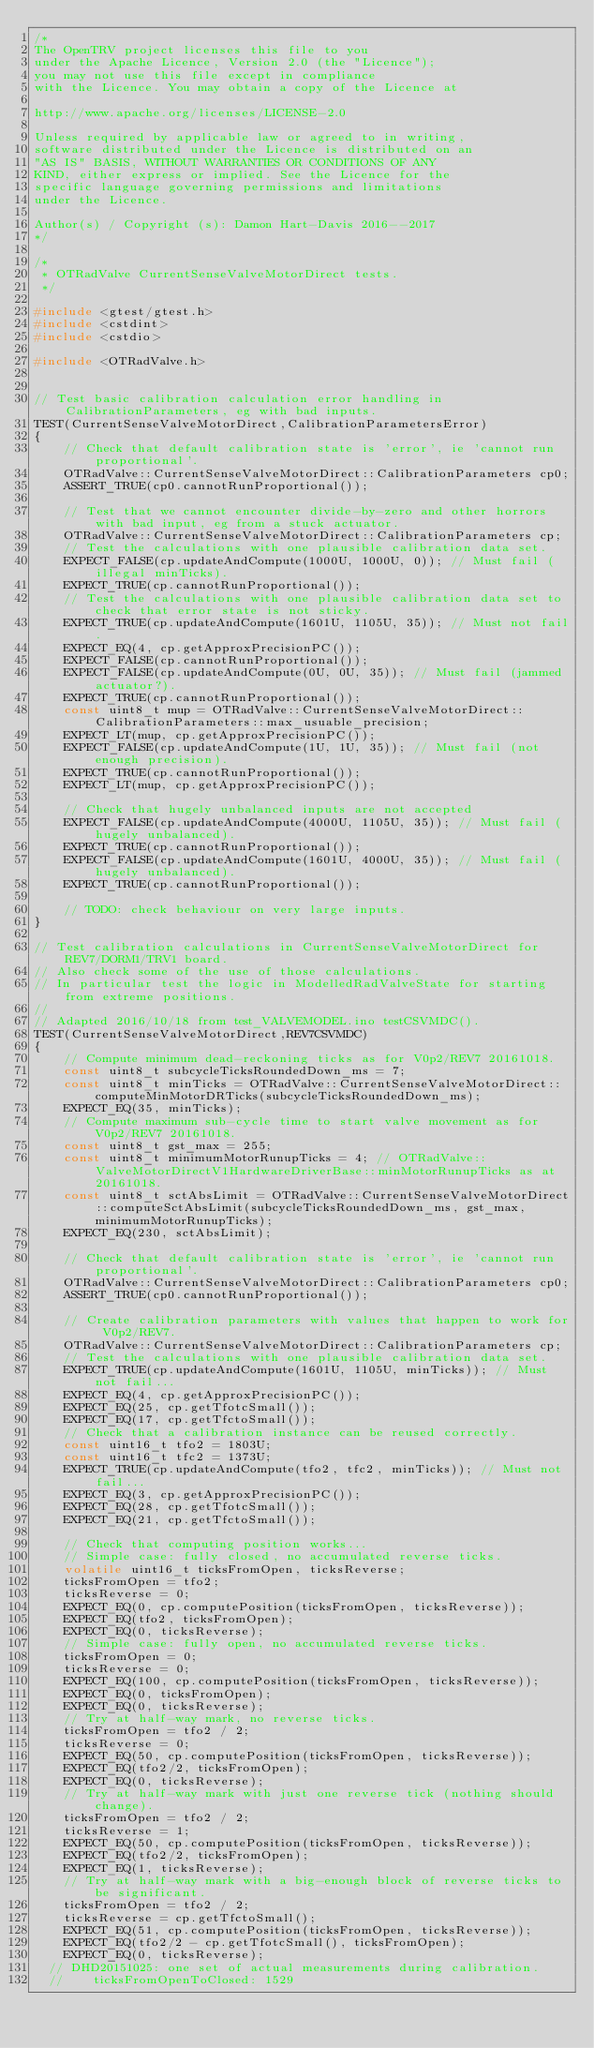Convert code to text. <code><loc_0><loc_0><loc_500><loc_500><_C++_>/*
The OpenTRV project licenses this file to you
under the Apache Licence, Version 2.0 (the "Licence");
you may not use this file except in compliance
with the Licence. You may obtain a copy of the Licence at

http://www.apache.org/licenses/LICENSE-2.0

Unless required by applicable law or agreed to in writing,
software distributed under the Licence is distributed on an
"AS IS" BASIS, WITHOUT WARRANTIES OR CONDITIONS OF ANY
KIND, either express or implied. See the Licence for the
specific language governing permissions and limitations
under the Licence.

Author(s) / Copyright (s): Damon Hart-Davis 2016--2017
*/

/*
 * OTRadValve CurrentSenseValveMotorDirect tests.
 */

#include <gtest/gtest.h>
#include <cstdint>
#include <cstdio>

#include <OTRadValve.h>


// Test basic calibration calculation error handling in CalibrationParameters, eg with bad inputs.
TEST(CurrentSenseValveMotorDirect,CalibrationParametersError)
{
    // Check that default calibration state is 'error', ie 'cannot run proportional'.
    OTRadValve::CurrentSenseValveMotorDirect::CalibrationParameters cp0;
    ASSERT_TRUE(cp0.cannotRunProportional());

    // Test that we cannot encounter divide-by-zero and other horrors with bad input, eg from a stuck actuator.
    OTRadValve::CurrentSenseValveMotorDirect::CalibrationParameters cp;
    // Test the calculations with one plausible calibration data set.
    EXPECT_FALSE(cp.updateAndCompute(1000U, 1000U, 0)); // Must fail (illegal minTicks).
    EXPECT_TRUE(cp.cannotRunProportional());
    // Test the calculations with one plausible calibration data set to check that error state is not sticky.
    EXPECT_TRUE(cp.updateAndCompute(1601U, 1105U, 35)); // Must not fail.
    EXPECT_EQ(4, cp.getApproxPrecisionPC());
    EXPECT_FALSE(cp.cannotRunProportional());
    EXPECT_FALSE(cp.updateAndCompute(0U, 0U, 35)); // Must fail (jammed actuator?).
    EXPECT_TRUE(cp.cannotRunProportional());
    const uint8_t mup = OTRadValve::CurrentSenseValveMotorDirect::CalibrationParameters::max_usuable_precision;
    EXPECT_LT(mup, cp.getApproxPrecisionPC());
    EXPECT_FALSE(cp.updateAndCompute(1U, 1U, 35)); // Must fail (not enough precision).
    EXPECT_TRUE(cp.cannotRunProportional());
    EXPECT_LT(mup, cp.getApproxPrecisionPC());

    // Check that hugely unbalanced inputs are not accepted
    EXPECT_FALSE(cp.updateAndCompute(4000U, 1105U, 35)); // Must fail (hugely unbalanced).
    EXPECT_TRUE(cp.cannotRunProportional());
    EXPECT_FALSE(cp.updateAndCompute(1601U, 4000U, 35)); // Must fail (hugely unbalanced).
    EXPECT_TRUE(cp.cannotRunProportional());

    // TODO: check behaviour on very large inputs.
}

// Test calibration calculations in CurrentSenseValveMotorDirect for REV7/DORM1/TRV1 board.
// Also check some of the use of those calculations.
// In particular test the logic in ModelledRadValveState for starting from extreme positions.
//
// Adapted 2016/10/18 from test_VALVEMODEL.ino testCSVMDC().
TEST(CurrentSenseValveMotorDirect,REV7CSVMDC)
{
    // Compute minimum dead-reckoning ticks as for V0p2/REV7 20161018.
    const uint8_t subcycleTicksRoundedDown_ms = 7;
    const uint8_t minTicks = OTRadValve::CurrentSenseValveMotorDirect::computeMinMotorDRTicks(subcycleTicksRoundedDown_ms);
    EXPECT_EQ(35, minTicks);
    // Compute maximum sub-cycle time to start valve movement as for V0p2/REV7 20161018.
    const uint8_t gst_max = 255;
    const uint8_t minimumMotorRunupTicks = 4; // OTRadValve::ValveMotorDirectV1HardwareDriverBase::minMotorRunupTicks as at 20161018.
    const uint8_t sctAbsLimit = OTRadValve::CurrentSenseValveMotorDirect::computeSctAbsLimit(subcycleTicksRoundedDown_ms, gst_max, minimumMotorRunupTicks);
    EXPECT_EQ(230, sctAbsLimit);

    // Check that default calibration state is 'error', ie 'cannot run proportional'.
    OTRadValve::CurrentSenseValveMotorDirect::CalibrationParameters cp0;
    ASSERT_TRUE(cp0.cannotRunProportional());

    // Create calibration parameters with values that happen to work for V0p2/REV7.
    OTRadValve::CurrentSenseValveMotorDirect::CalibrationParameters cp;
    // Test the calculations with one plausible calibration data set.
    EXPECT_TRUE(cp.updateAndCompute(1601U, 1105U, minTicks)); // Must not fail...
    EXPECT_EQ(4, cp.getApproxPrecisionPC());
    EXPECT_EQ(25, cp.getTfotcSmall());
    EXPECT_EQ(17, cp.getTfctoSmall());
    // Check that a calibration instance can be reused correctly.
    const uint16_t tfo2 = 1803U;
    const uint16_t tfc2 = 1373U;
    EXPECT_TRUE(cp.updateAndCompute(tfo2, tfc2, minTicks)); // Must not fail...
    EXPECT_EQ(3, cp.getApproxPrecisionPC());
    EXPECT_EQ(28, cp.getTfotcSmall());
    EXPECT_EQ(21, cp.getTfctoSmall());

    // Check that computing position works...
    // Simple case: fully closed, no accumulated reverse ticks.
    volatile uint16_t ticksFromOpen, ticksReverse;
    ticksFromOpen = tfo2;
    ticksReverse = 0;
    EXPECT_EQ(0, cp.computePosition(ticksFromOpen, ticksReverse));
    EXPECT_EQ(tfo2, ticksFromOpen);
    EXPECT_EQ(0, ticksReverse);
    // Simple case: fully open, no accumulated reverse ticks.
    ticksFromOpen = 0;
    ticksReverse = 0;
    EXPECT_EQ(100, cp.computePosition(ticksFromOpen, ticksReverse));
    EXPECT_EQ(0, ticksFromOpen);
    EXPECT_EQ(0, ticksReverse);
    // Try at half-way mark, no reverse ticks.
    ticksFromOpen = tfo2 / 2;
    ticksReverse = 0;
    EXPECT_EQ(50, cp.computePosition(ticksFromOpen, ticksReverse));
    EXPECT_EQ(tfo2/2, ticksFromOpen);
    EXPECT_EQ(0, ticksReverse);
    // Try at half-way mark with just one reverse tick (nothing should change).
    ticksFromOpen = tfo2 / 2;
    ticksReverse = 1;
    EXPECT_EQ(50, cp.computePosition(ticksFromOpen, ticksReverse));
    EXPECT_EQ(tfo2/2, ticksFromOpen);
    EXPECT_EQ(1, ticksReverse);
    // Try at half-way mark with a big-enough block of reverse ticks to be significant.
    ticksFromOpen = tfo2 / 2;
    ticksReverse = cp.getTfctoSmall();
    EXPECT_EQ(51, cp.computePosition(ticksFromOpen, ticksReverse));
    EXPECT_EQ(tfo2/2 - cp.getTfotcSmall(), ticksFromOpen);
    EXPECT_EQ(0, ticksReverse);
  // DHD20151025: one set of actual measurements during calibration.
  //    ticksFromOpenToClosed: 1529</code> 